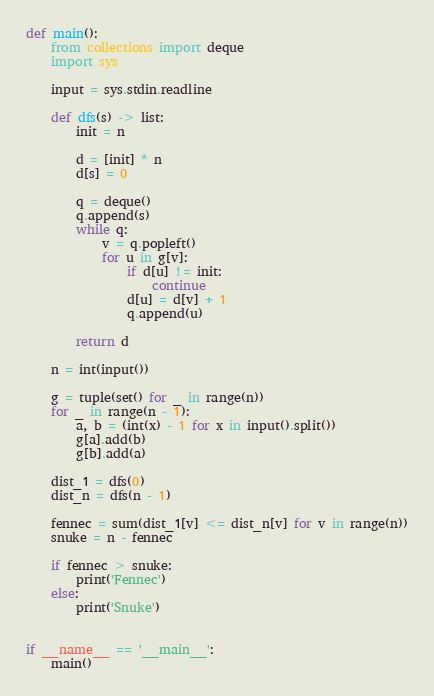<code> <loc_0><loc_0><loc_500><loc_500><_Python_>def main():
    from collections import deque
    import sys

    input = sys.stdin.readline

    def dfs(s) -> list:
        init = n

        d = [init] * n
        d[s] = 0

        q = deque()
        q.append(s)
        while q:
            v = q.popleft()
            for u in g[v]:
                if d[u] != init:
                    continue
                d[u] = d[v] + 1
                q.append(u)

        return d

    n = int(input())

    g = tuple(set() for _ in range(n))
    for _ in range(n - 1):
        a, b = (int(x) - 1 for x in input().split())
        g[a].add(b)
        g[b].add(a)

    dist_1 = dfs(0)
    dist_n = dfs(n - 1)

    fennec = sum(dist_1[v] <= dist_n[v] for v in range(n))
    snuke = n - fennec

    if fennec > snuke:
        print('Fennec')
    else:
        print('Snuke')


if __name__ == '__main__':
    main()
</code> 